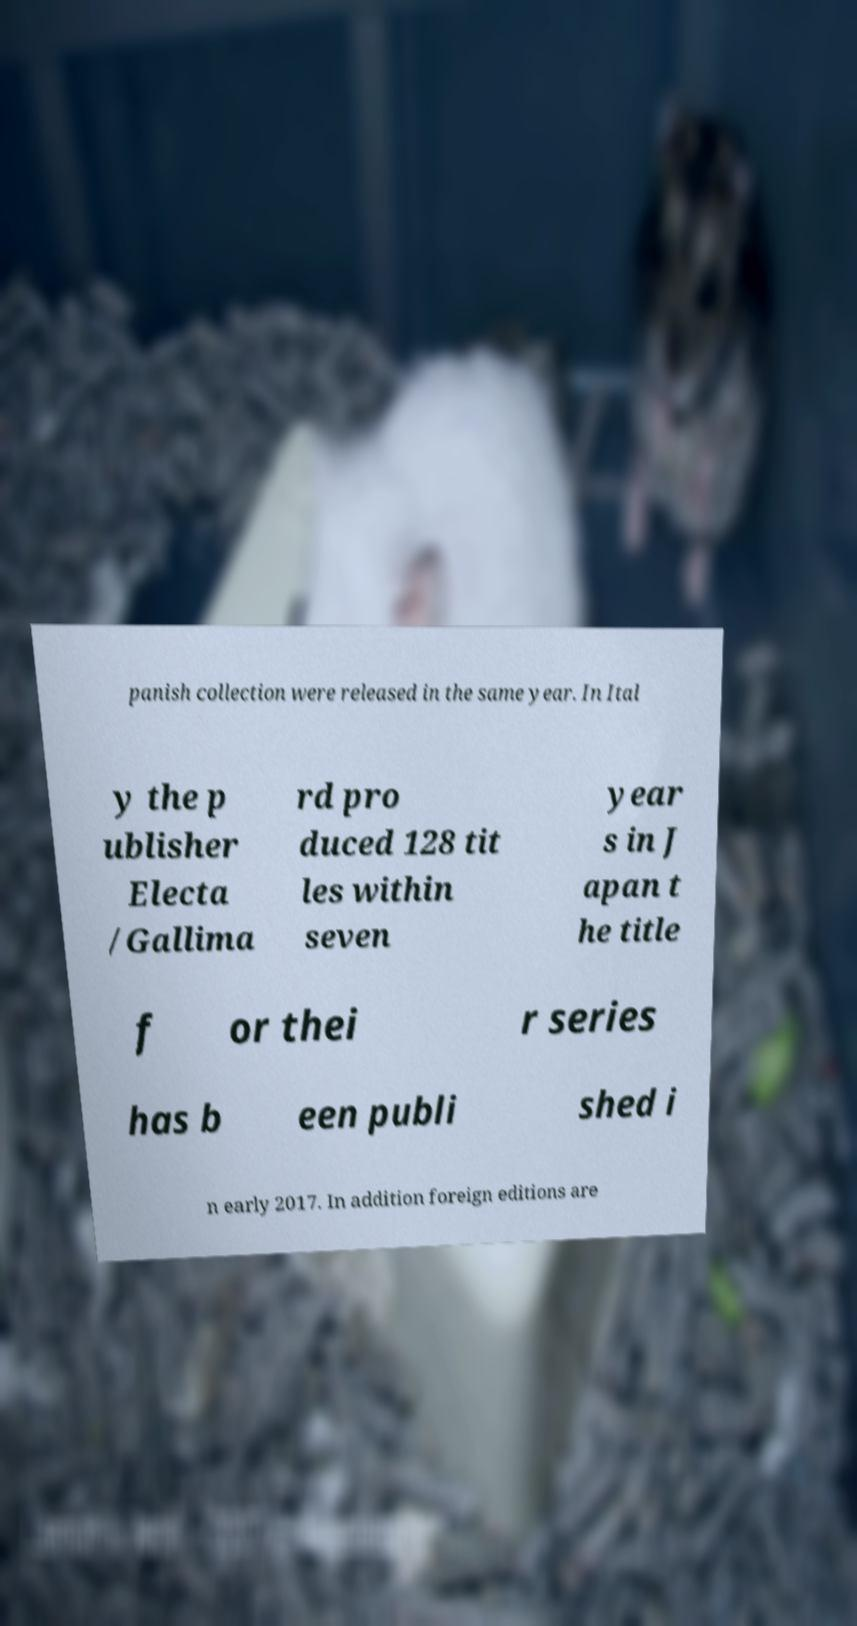What messages or text are displayed in this image? I need them in a readable, typed format. panish collection were released in the same year. In Ital y the p ublisher Electa /Gallima rd pro duced 128 tit les within seven year s in J apan t he title f or thei r series has b een publi shed i n early 2017. In addition foreign editions are 